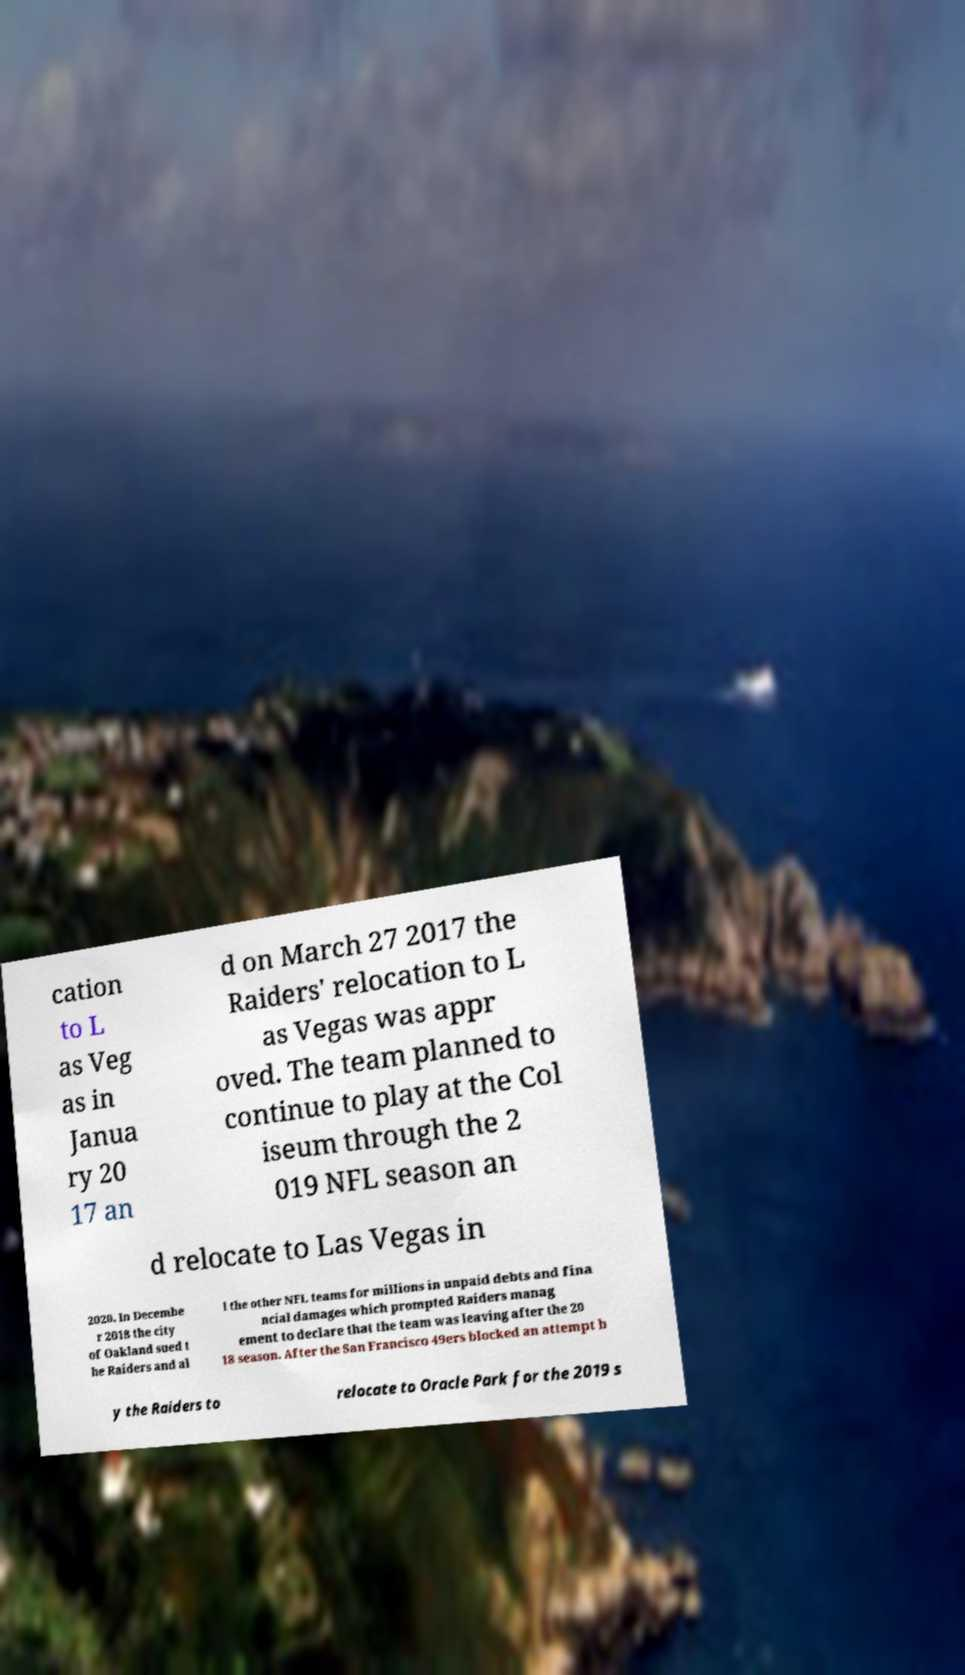Could you assist in decoding the text presented in this image and type it out clearly? cation to L as Veg as in Janua ry 20 17 an d on March 27 2017 the Raiders' relocation to L as Vegas was appr oved. The team planned to continue to play at the Col iseum through the 2 019 NFL season an d relocate to Las Vegas in 2020. In Decembe r 2018 the city of Oakland sued t he Raiders and al l the other NFL teams for millions in unpaid debts and fina ncial damages which prompted Raiders manag ement to declare that the team was leaving after the 20 18 season. After the San Francisco 49ers blocked an attempt b y the Raiders to relocate to Oracle Park for the 2019 s 